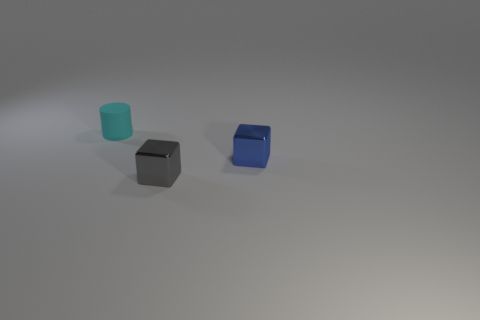Add 3 blue metal blocks. How many objects exist? 6 Subtract all cylinders. How many objects are left? 2 Add 1 tiny gray things. How many tiny gray things are left? 2 Add 2 small purple rubber objects. How many small purple rubber objects exist? 2 Subtract 1 blue cubes. How many objects are left? 2 Subtract all small gray things. Subtract all tiny gray metal things. How many objects are left? 1 